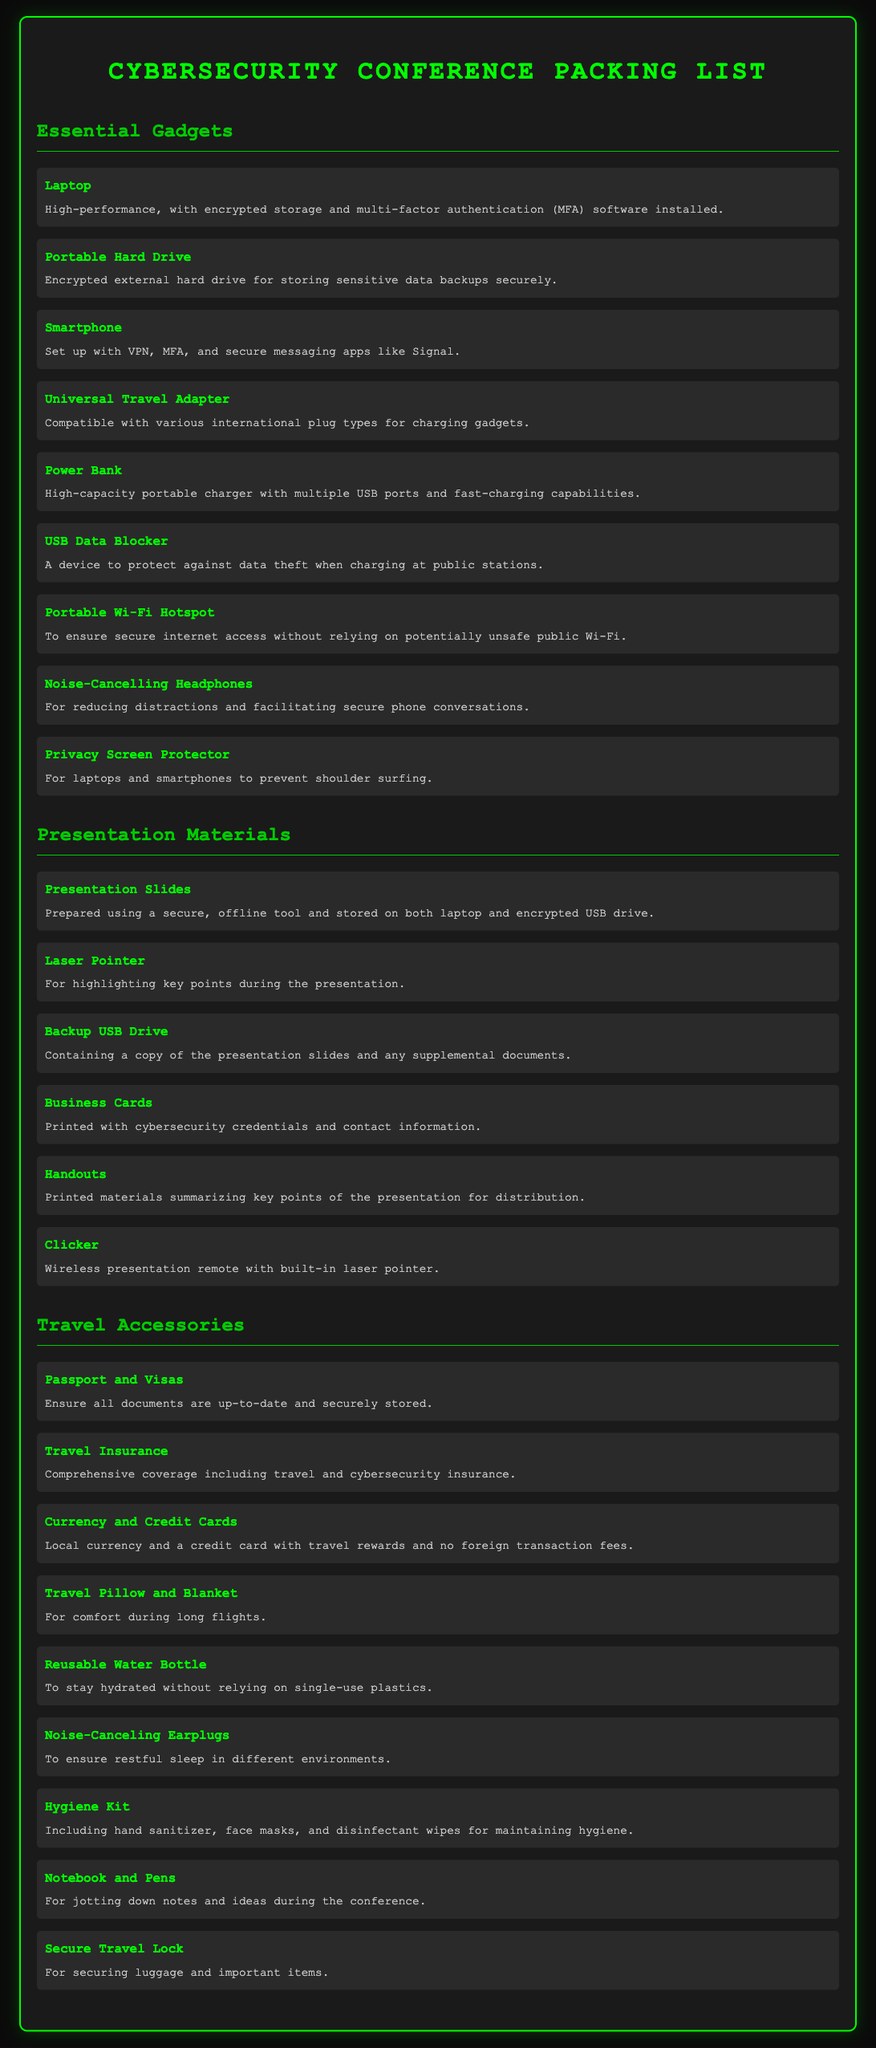What is the first item listed under Essential Gadgets? The first item listed is "Laptop."
Answer: Laptop How many items are listed under Presentation Materials? There are six items listed under Presentation Materials.
Answer: 6 What device is used to prevent data theft while charging? The device is called a "USB Data Blocker."
Answer: USB Data Blocker What type of headphones are recommended? The recommended type is "Noise-Cancelling Headphones."
Answer: Noise-Cancelling Headphones What should you ensure is up-to-date before traveling? You should ensure that "Passport and Visas" are up-to-date.
Answer: Passport and Visas Which travel accessory is mentioned for comfort during long flights? The accessory mentioned for comfort is "Travel Pillow and Blanket."
Answer: Travel Pillow and Blanket What is recommended to ensure secure internet access? A "Portable Wi-Fi Hotspot" is recommended.
Answer: Portable Wi-Fi Hotspot How many items are listed under Travel Accessories? There are eight items listed under Travel Accessories.
Answer: 8 What are the printed materials that summarize key points of the presentation called? They are called "Handouts."
Answer: Handouts 